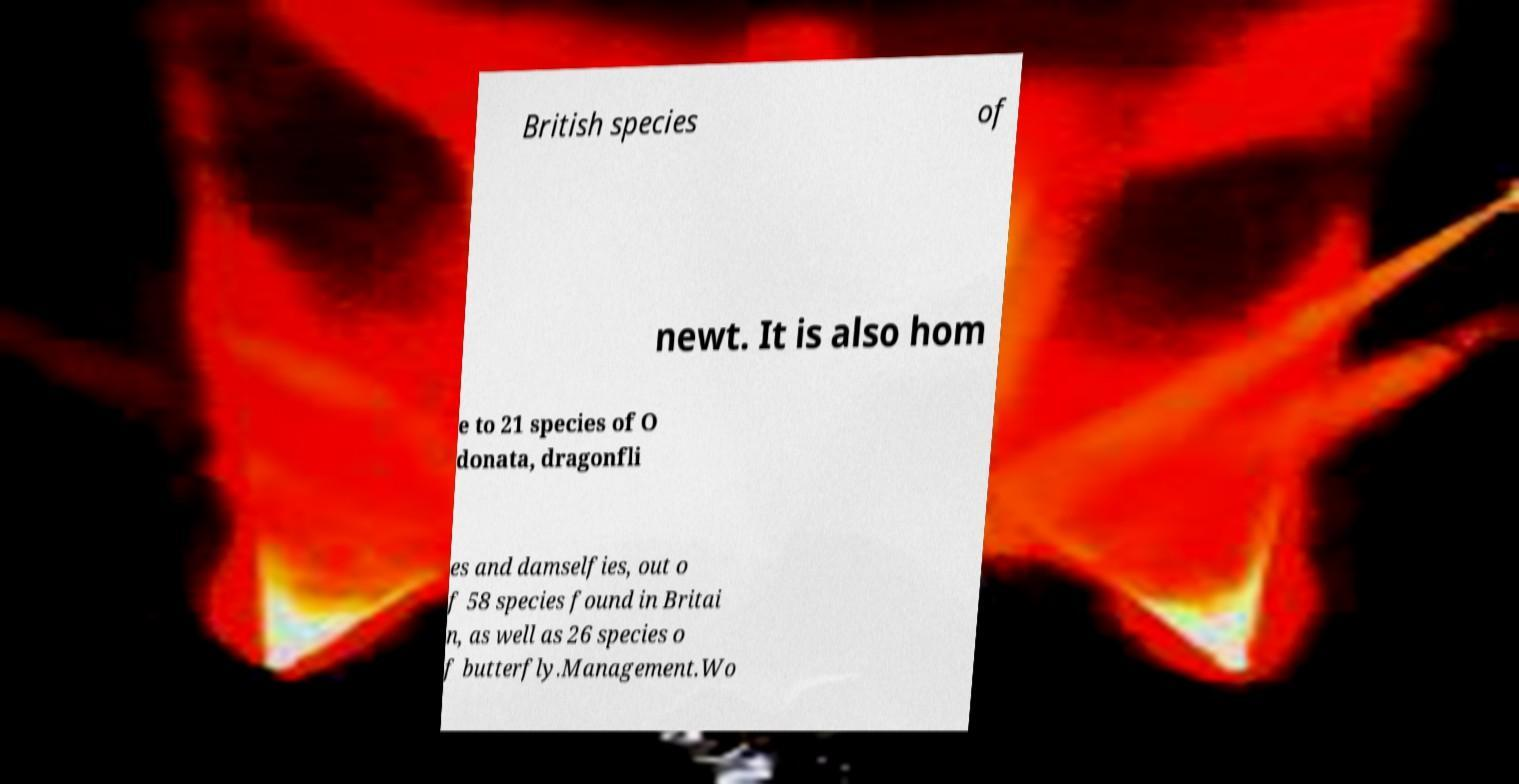Can you accurately transcribe the text from the provided image for me? British species of newt. It is also hom e to 21 species of O donata, dragonfli es and damselfies, out o f 58 species found in Britai n, as well as 26 species o f butterfly.Management.Wo 